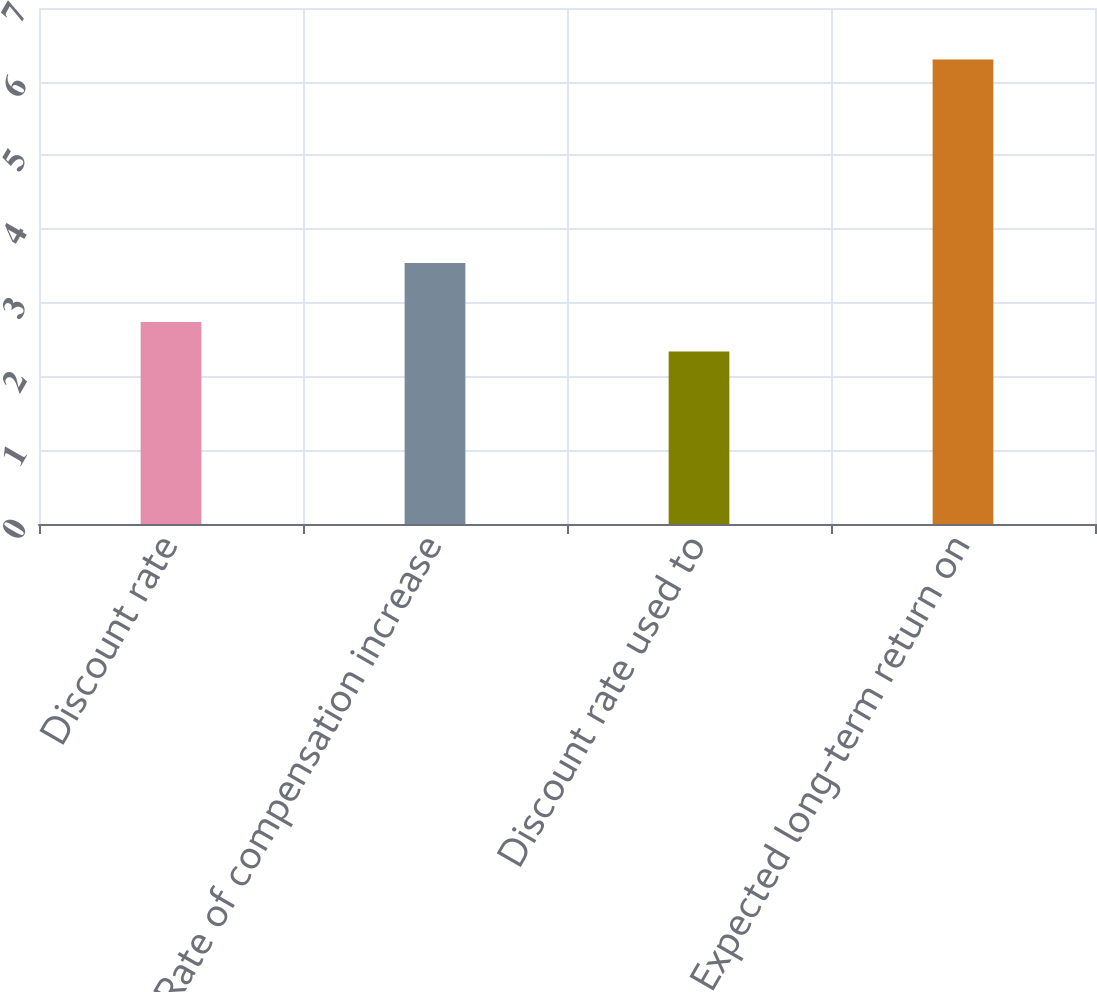Convert chart to OTSL. <chart><loc_0><loc_0><loc_500><loc_500><bar_chart><fcel>Discount rate<fcel>Rate of compensation increase<fcel>Discount rate used to<fcel>Expected long-term return on<nl><fcel>2.74<fcel>3.54<fcel>2.34<fcel>6.3<nl></chart> 